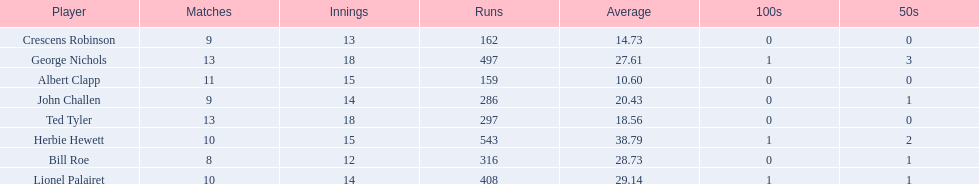Parse the full table in json format. {'header': ['Player', 'Matches', 'Innings', 'Runs', 'Average', '100s', '50s'], 'rows': [['Crescens Robinson', '9', '13', '162', '14.73', '0', '0'], ['George Nichols', '13', '18', '497', '27.61', '1', '3'], ['Albert Clapp', '11', '15', '159', '10.60', '0', '0'], ['John Challen', '9', '14', '286', '20.43', '0', '1'], ['Ted Tyler', '13', '18', '297', '18.56', '0', '0'], ['Herbie Hewett', '10', '15', '543', '38.79', '1', '2'], ['Bill Roe', '8', '12', '316', '28.73', '0', '1'], ['Lionel Palairet', '10', '14', '408', '29.14', '1', '1']]} Who are the players in somerset county cricket club in 1890? Herbie Hewett, Lionel Palairet, Bill Roe, George Nichols, John Challen, Ted Tyler, Crescens Robinson, Albert Clapp. Who is the only player to play less than 13 innings? Bill Roe. 